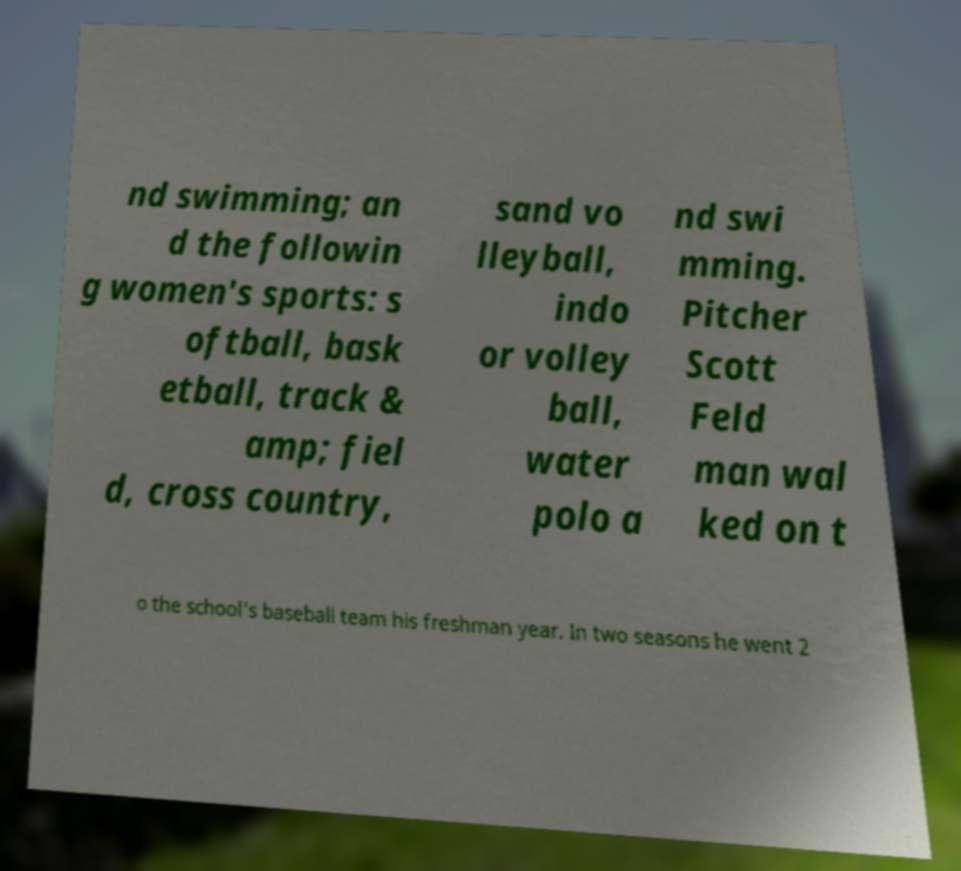Please read and relay the text visible in this image. What does it say? nd swimming; an d the followin g women's sports: s oftball, bask etball, track & amp; fiel d, cross country, sand vo lleyball, indo or volley ball, water polo a nd swi mming. Pitcher Scott Feld man wal ked on t o the school's baseball team his freshman year. In two seasons he went 2 